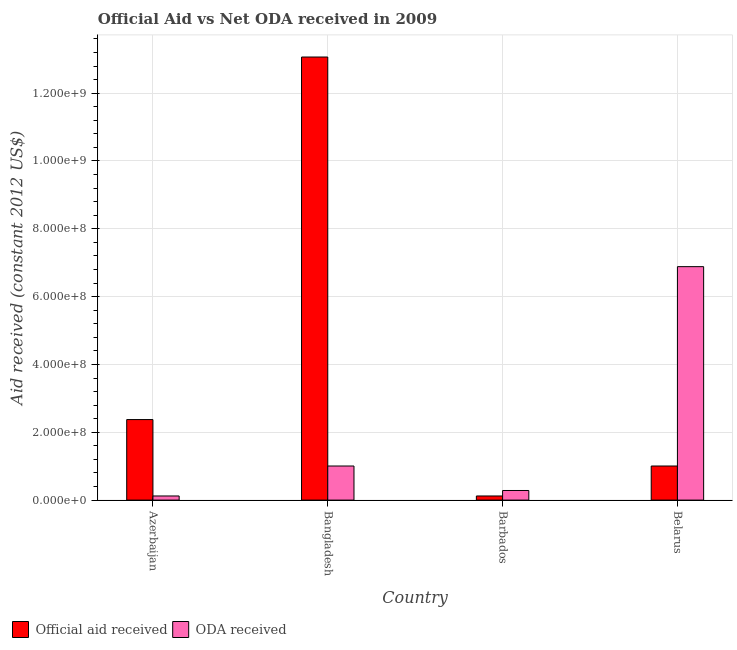How many groups of bars are there?
Your answer should be compact. 4. How many bars are there on the 4th tick from the left?
Ensure brevity in your answer.  2. How many bars are there on the 2nd tick from the right?
Make the answer very short. 2. What is the label of the 3rd group of bars from the left?
Make the answer very short. Barbados. What is the oda received in Belarus?
Keep it short and to the point. 6.88e+08. Across all countries, what is the maximum oda received?
Make the answer very short. 6.88e+08. Across all countries, what is the minimum oda received?
Keep it short and to the point. 1.22e+07. In which country was the official aid received maximum?
Give a very brief answer. Bangladesh. In which country was the official aid received minimum?
Offer a very short reply. Barbados. What is the total oda received in the graph?
Your response must be concise. 8.29e+08. What is the difference between the official aid received in Azerbaijan and that in Belarus?
Offer a terse response. 1.37e+08. What is the difference between the oda received in Azerbaijan and the official aid received in Barbados?
Offer a very short reply. 0. What is the average oda received per country?
Your answer should be very brief. 2.07e+08. What is the difference between the oda received and official aid received in Bangladesh?
Give a very brief answer. -1.21e+09. In how many countries, is the official aid received greater than 880000000 US$?
Your answer should be compact. 1. What is the ratio of the official aid received in Azerbaijan to that in Belarus?
Your response must be concise. 2.36. What is the difference between the highest and the second highest oda received?
Keep it short and to the point. 5.88e+08. What is the difference between the highest and the lowest oda received?
Provide a succinct answer. 6.76e+08. What does the 1st bar from the left in Azerbaijan represents?
Your answer should be compact. Official aid received. What does the 2nd bar from the right in Azerbaijan represents?
Your answer should be compact. Official aid received. How many bars are there?
Your response must be concise. 8. Are all the bars in the graph horizontal?
Your answer should be very brief. No. How many countries are there in the graph?
Offer a very short reply. 4. What is the difference between two consecutive major ticks on the Y-axis?
Your answer should be very brief. 2.00e+08. Does the graph contain any zero values?
Your answer should be very brief. No. Where does the legend appear in the graph?
Give a very brief answer. Bottom left. How are the legend labels stacked?
Give a very brief answer. Horizontal. What is the title of the graph?
Your answer should be very brief. Official Aid vs Net ODA received in 2009 . What is the label or title of the Y-axis?
Your answer should be very brief. Aid received (constant 2012 US$). What is the Aid received (constant 2012 US$) of Official aid received in Azerbaijan?
Your response must be concise. 2.37e+08. What is the Aid received (constant 2012 US$) in ODA received in Azerbaijan?
Your response must be concise. 1.22e+07. What is the Aid received (constant 2012 US$) in Official aid received in Bangladesh?
Provide a short and direct response. 1.31e+09. What is the Aid received (constant 2012 US$) in ODA received in Bangladesh?
Provide a short and direct response. 1.01e+08. What is the Aid received (constant 2012 US$) of Official aid received in Barbados?
Offer a terse response. 1.22e+07. What is the Aid received (constant 2012 US$) in ODA received in Barbados?
Keep it short and to the point. 2.83e+07. What is the Aid received (constant 2012 US$) in Official aid received in Belarus?
Make the answer very short. 1.01e+08. What is the Aid received (constant 2012 US$) of ODA received in Belarus?
Ensure brevity in your answer.  6.88e+08. Across all countries, what is the maximum Aid received (constant 2012 US$) in Official aid received?
Your response must be concise. 1.31e+09. Across all countries, what is the maximum Aid received (constant 2012 US$) of ODA received?
Your answer should be compact. 6.88e+08. Across all countries, what is the minimum Aid received (constant 2012 US$) in Official aid received?
Keep it short and to the point. 1.22e+07. Across all countries, what is the minimum Aid received (constant 2012 US$) of ODA received?
Make the answer very short. 1.22e+07. What is the total Aid received (constant 2012 US$) of Official aid received in the graph?
Provide a succinct answer. 1.66e+09. What is the total Aid received (constant 2012 US$) of ODA received in the graph?
Offer a very short reply. 8.29e+08. What is the difference between the Aid received (constant 2012 US$) in Official aid received in Azerbaijan and that in Bangladesh?
Provide a succinct answer. -1.07e+09. What is the difference between the Aid received (constant 2012 US$) in ODA received in Azerbaijan and that in Bangladesh?
Make the answer very short. -8.83e+07. What is the difference between the Aid received (constant 2012 US$) of Official aid received in Azerbaijan and that in Barbados?
Give a very brief answer. 2.25e+08. What is the difference between the Aid received (constant 2012 US$) in ODA received in Azerbaijan and that in Barbados?
Provide a short and direct response. -1.62e+07. What is the difference between the Aid received (constant 2012 US$) in Official aid received in Azerbaijan and that in Belarus?
Keep it short and to the point. 1.37e+08. What is the difference between the Aid received (constant 2012 US$) in ODA received in Azerbaijan and that in Belarus?
Offer a very short reply. -6.76e+08. What is the difference between the Aid received (constant 2012 US$) in Official aid received in Bangladesh and that in Barbados?
Provide a succinct answer. 1.29e+09. What is the difference between the Aid received (constant 2012 US$) of ODA received in Bangladesh and that in Barbados?
Provide a succinct answer. 7.22e+07. What is the difference between the Aid received (constant 2012 US$) in Official aid received in Bangladesh and that in Belarus?
Your answer should be very brief. 1.21e+09. What is the difference between the Aid received (constant 2012 US$) in ODA received in Bangladesh and that in Belarus?
Your response must be concise. -5.88e+08. What is the difference between the Aid received (constant 2012 US$) of Official aid received in Barbados and that in Belarus?
Offer a very short reply. -8.83e+07. What is the difference between the Aid received (constant 2012 US$) of ODA received in Barbados and that in Belarus?
Your answer should be compact. -6.60e+08. What is the difference between the Aid received (constant 2012 US$) in Official aid received in Azerbaijan and the Aid received (constant 2012 US$) in ODA received in Bangladesh?
Ensure brevity in your answer.  1.37e+08. What is the difference between the Aid received (constant 2012 US$) in Official aid received in Azerbaijan and the Aid received (constant 2012 US$) in ODA received in Barbados?
Your answer should be compact. 2.09e+08. What is the difference between the Aid received (constant 2012 US$) of Official aid received in Azerbaijan and the Aid received (constant 2012 US$) of ODA received in Belarus?
Offer a very short reply. -4.51e+08. What is the difference between the Aid received (constant 2012 US$) of Official aid received in Bangladesh and the Aid received (constant 2012 US$) of ODA received in Barbados?
Keep it short and to the point. 1.28e+09. What is the difference between the Aid received (constant 2012 US$) of Official aid received in Bangladesh and the Aid received (constant 2012 US$) of ODA received in Belarus?
Offer a terse response. 6.18e+08. What is the difference between the Aid received (constant 2012 US$) of Official aid received in Barbados and the Aid received (constant 2012 US$) of ODA received in Belarus?
Your answer should be very brief. -6.76e+08. What is the average Aid received (constant 2012 US$) in Official aid received per country?
Your response must be concise. 4.14e+08. What is the average Aid received (constant 2012 US$) of ODA received per country?
Provide a short and direct response. 2.07e+08. What is the difference between the Aid received (constant 2012 US$) in Official aid received and Aid received (constant 2012 US$) in ODA received in Azerbaijan?
Ensure brevity in your answer.  2.25e+08. What is the difference between the Aid received (constant 2012 US$) of Official aid received and Aid received (constant 2012 US$) of ODA received in Bangladesh?
Make the answer very short. 1.21e+09. What is the difference between the Aid received (constant 2012 US$) of Official aid received and Aid received (constant 2012 US$) of ODA received in Barbados?
Offer a terse response. -1.62e+07. What is the difference between the Aid received (constant 2012 US$) of Official aid received and Aid received (constant 2012 US$) of ODA received in Belarus?
Make the answer very short. -5.88e+08. What is the ratio of the Aid received (constant 2012 US$) of Official aid received in Azerbaijan to that in Bangladesh?
Keep it short and to the point. 0.18. What is the ratio of the Aid received (constant 2012 US$) of ODA received in Azerbaijan to that in Bangladesh?
Give a very brief answer. 0.12. What is the ratio of the Aid received (constant 2012 US$) in Official aid received in Azerbaijan to that in Barbados?
Make the answer very short. 19.5. What is the ratio of the Aid received (constant 2012 US$) in ODA received in Azerbaijan to that in Barbados?
Provide a succinct answer. 0.43. What is the ratio of the Aid received (constant 2012 US$) in Official aid received in Azerbaijan to that in Belarus?
Keep it short and to the point. 2.36. What is the ratio of the Aid received (constant 2012 US$) in ODA received in Azerbaijan to that in Belarus?
Your response must be concise. 0.02. What is the ratio of the Aid received (constant 2012 US$) in Official aid received in Bangladesh to that in Barbados?
Your answer should be very brief. 107.26. What is the ratio of the Aid received (constant 2012 US$) of ODA received in Bangladesh to that in Barbados?
Offer a very short reply. 3.55. What is the ratio of the Aid received (constant 2012 US$) in Official aid received in Bangladesh to that in Belarus?
Provide a short and direct response. 13. What is the ratio of the Aid received (constant 2012 US$) of ODA received in Bangladesh to that in Belarus?
Offer a terse response. 0.15. What is the ratio of the Aid received (constant 2012 US$) in Official aid received in Barbados to that in Belarus?
Your answer should be compact. 0.12. What is the ratio of the Aid received (constant 2012 US$) in ODA received in Barbados to that in Belarus?
Your answer should be very brief. 0.04. What is the difference between the highest and the second highest Aid received (constant 2012 US$) in Official aid received?
Ensure brevity in your answer.  1.07e+09. What is the difference between the highest and the second highest Aid received (constant 2012 US$) in ODA received?
Your response must be concise. 5.88e+08. What is the difference between the highest and the lowest Aid received (constant 2012 US$) in Official aid received?
Your response must be concise. 1.29e+09. What is the difference between the highest and the lowest Aid received (constant 2012 US$) in ODA received?
Provide a succinct answer. 6.76e+08. 